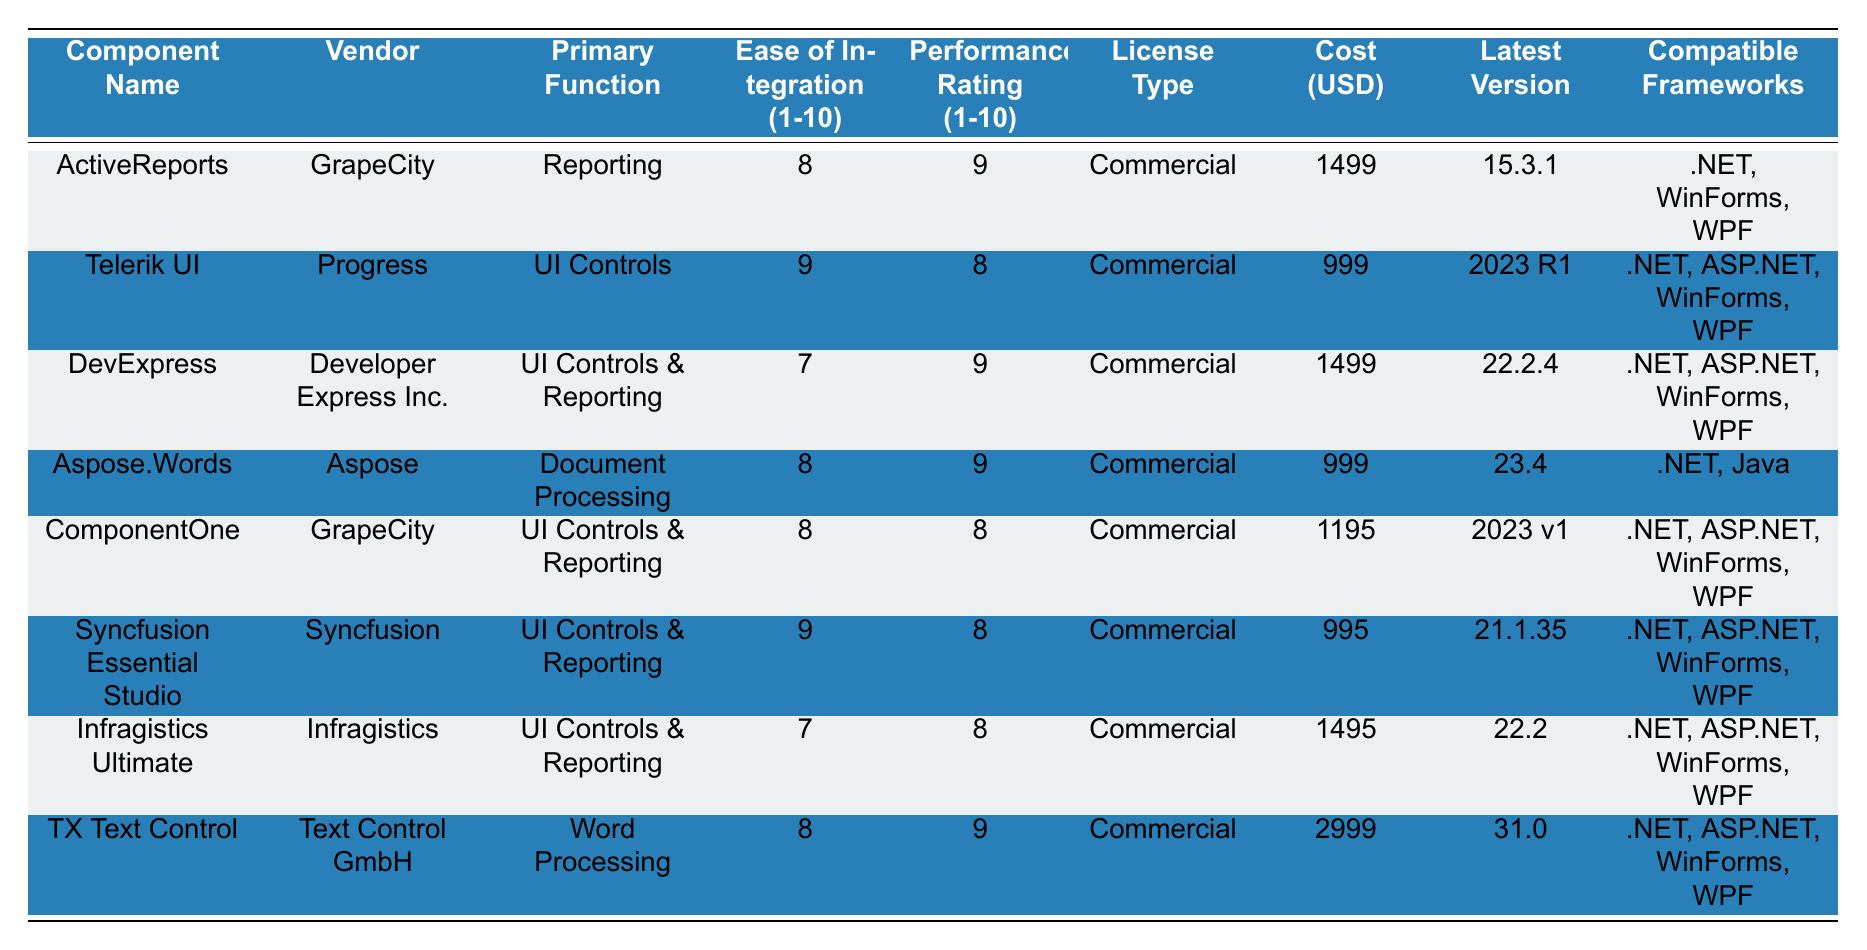What are the primary functions of the components from GrapeCity? The two components from GrapeCity are ActiveReports and ComponentOne. ActiveReports is for Reporting and ComponentOne is for UI Controls & Reporting.
Answer: Reporting and UI Controls & Reporting Which component has the highest cost? The component with the highest cost is TX Text Control, which costs $2999.
Answer: TX Text Control What is the average ease of integration rating for all components listed? The ratings are 8, 9, 7, 8, 8, 9, 7, and 8, which sum up to 66. There are 8 components, so the average is 66/8 = 8.25.
Answer: 8.25 Is Telerik UI easier to integrate than DevExpress? Telerik UI has an ease of integration rating of 9, while DevExpress has a rating of 7. Since 9 is greater than 7, the statement is true.
Answer: Yes Which vendor provides the lowest-cost component? The lowest cost is for Telerik UI at $999.
Answer: Progress How many components have a performance rating of 9? ActiveReports, Aspose.Words, and TX Text Control have a performance rating of 9, totaling three components.
Answer: 3 Is there a component that specializes in Document Processing? Yes, Aspose.Words specializes in Document Processing.
Answer: Yes What is the difference in cost between ComponentOne and Telerik UI? ComponentOne costs $1195, and Telerik UI costs $999. The difference is $1195 - $999 = $196.
Answer: $196 Which components are compatible with both .NET and ASP.NET frameworks? The components compatible with both frameworks are Telerik UI, DevExpress, ComponentOne, Syncfusion Essential Studio, Infragistics Ultimate, and TX Text Control.
Answer: 6 components 